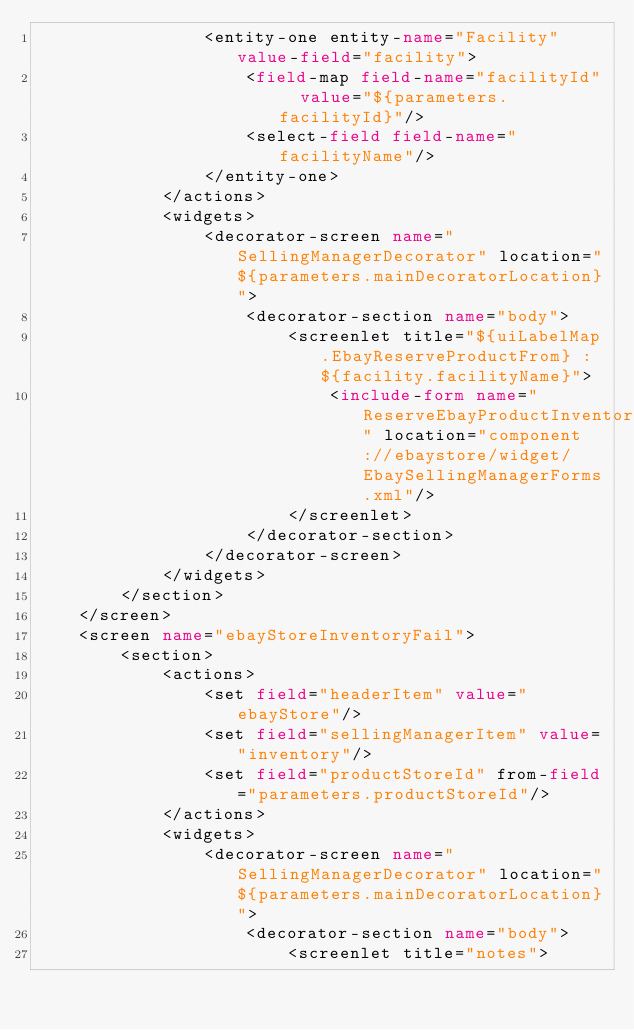<code> <loc_0><loc_0><loc_500><loc_500><_XML_>                <entity-one entity-name="Facility" value-field="facility">
                    <field-map field-name="facilityId"  value="${parameters.facilityId}"/>
                    <select-field field-name="facilityName"/>
                </entity-one>
            </actions>
            <widgets>
                <decorator-screen name="SellingManagerDecorator" location="${parameters.mainDecoratorLocation}">
                    <decorator-section name="body">
                        <screenlet title="${uiLabelMap.EbayReserveProductFrom} : ${facility.facilityName}">
                            <include-form name="ReserveEbayProductInventory" location="component://ebaystore/widget/EbaySellingManagerForms.xml"/>
                        </screenlet>
                    </decorator-section>
                </decorator-screen>
            </widgets>
        </section>
    </screen>
    <screen name="ebayStoreInventoryFail">
        <section>
            <actions>
                <set field="headerItem" value="ebayStore"/>
                <set field="sellingManagerItem" value="inventory"/>
                <set field="productStoreId" from-field="parameters.productStoreId"/>
            </actions>
            <widgets>
                <decorator-screen name="SellingManagerDecorator" location="${parameters.mainDecoratorLocation}">
                    <decorator-section name="body">
                        <screenlet title="notes"></code> 